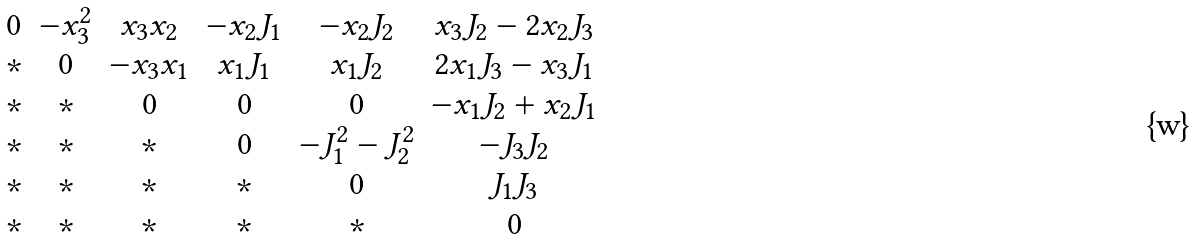Convert formula to latex. <formula><loc_0><loc_0><loc_500><loc_500>\begin{matrix} 0 & - x _ { 3 } ^ { 2 } & x _ { 3 } x _ { 2 } & - x _ { 2 } J _ { 1 } & - x _ { 2 } J _ { 2 } & x _ { 3 } J _ { 2 } - 2 x _ { 2 } J _ { 3 } \\ * & 0 & - x _ { 3 } x _ { 1 } & x _ { 1 } J _ { 1 } & x _ { 1 } J _ { 2 } & 2 x _ { 1 } J _ { 3 } - x _ { 3 } J _ { 1 } \\ * & * & 0 & 0 & 0 & - x _ { 1 } J _ { 2 } + x _ { 2 } J _ { 1 } \\ * & * & * & 0 & - J _ { 1 } ^ { 2 } - J _ { 2 } ^ { 2 } & - J _ { 3 } J _ { 2 } \\ * & * & * & * & 0 & J _ { 1 } J _ { 3 } \\ * & * & * & * & * & 0 \end{matrix}</formula> 